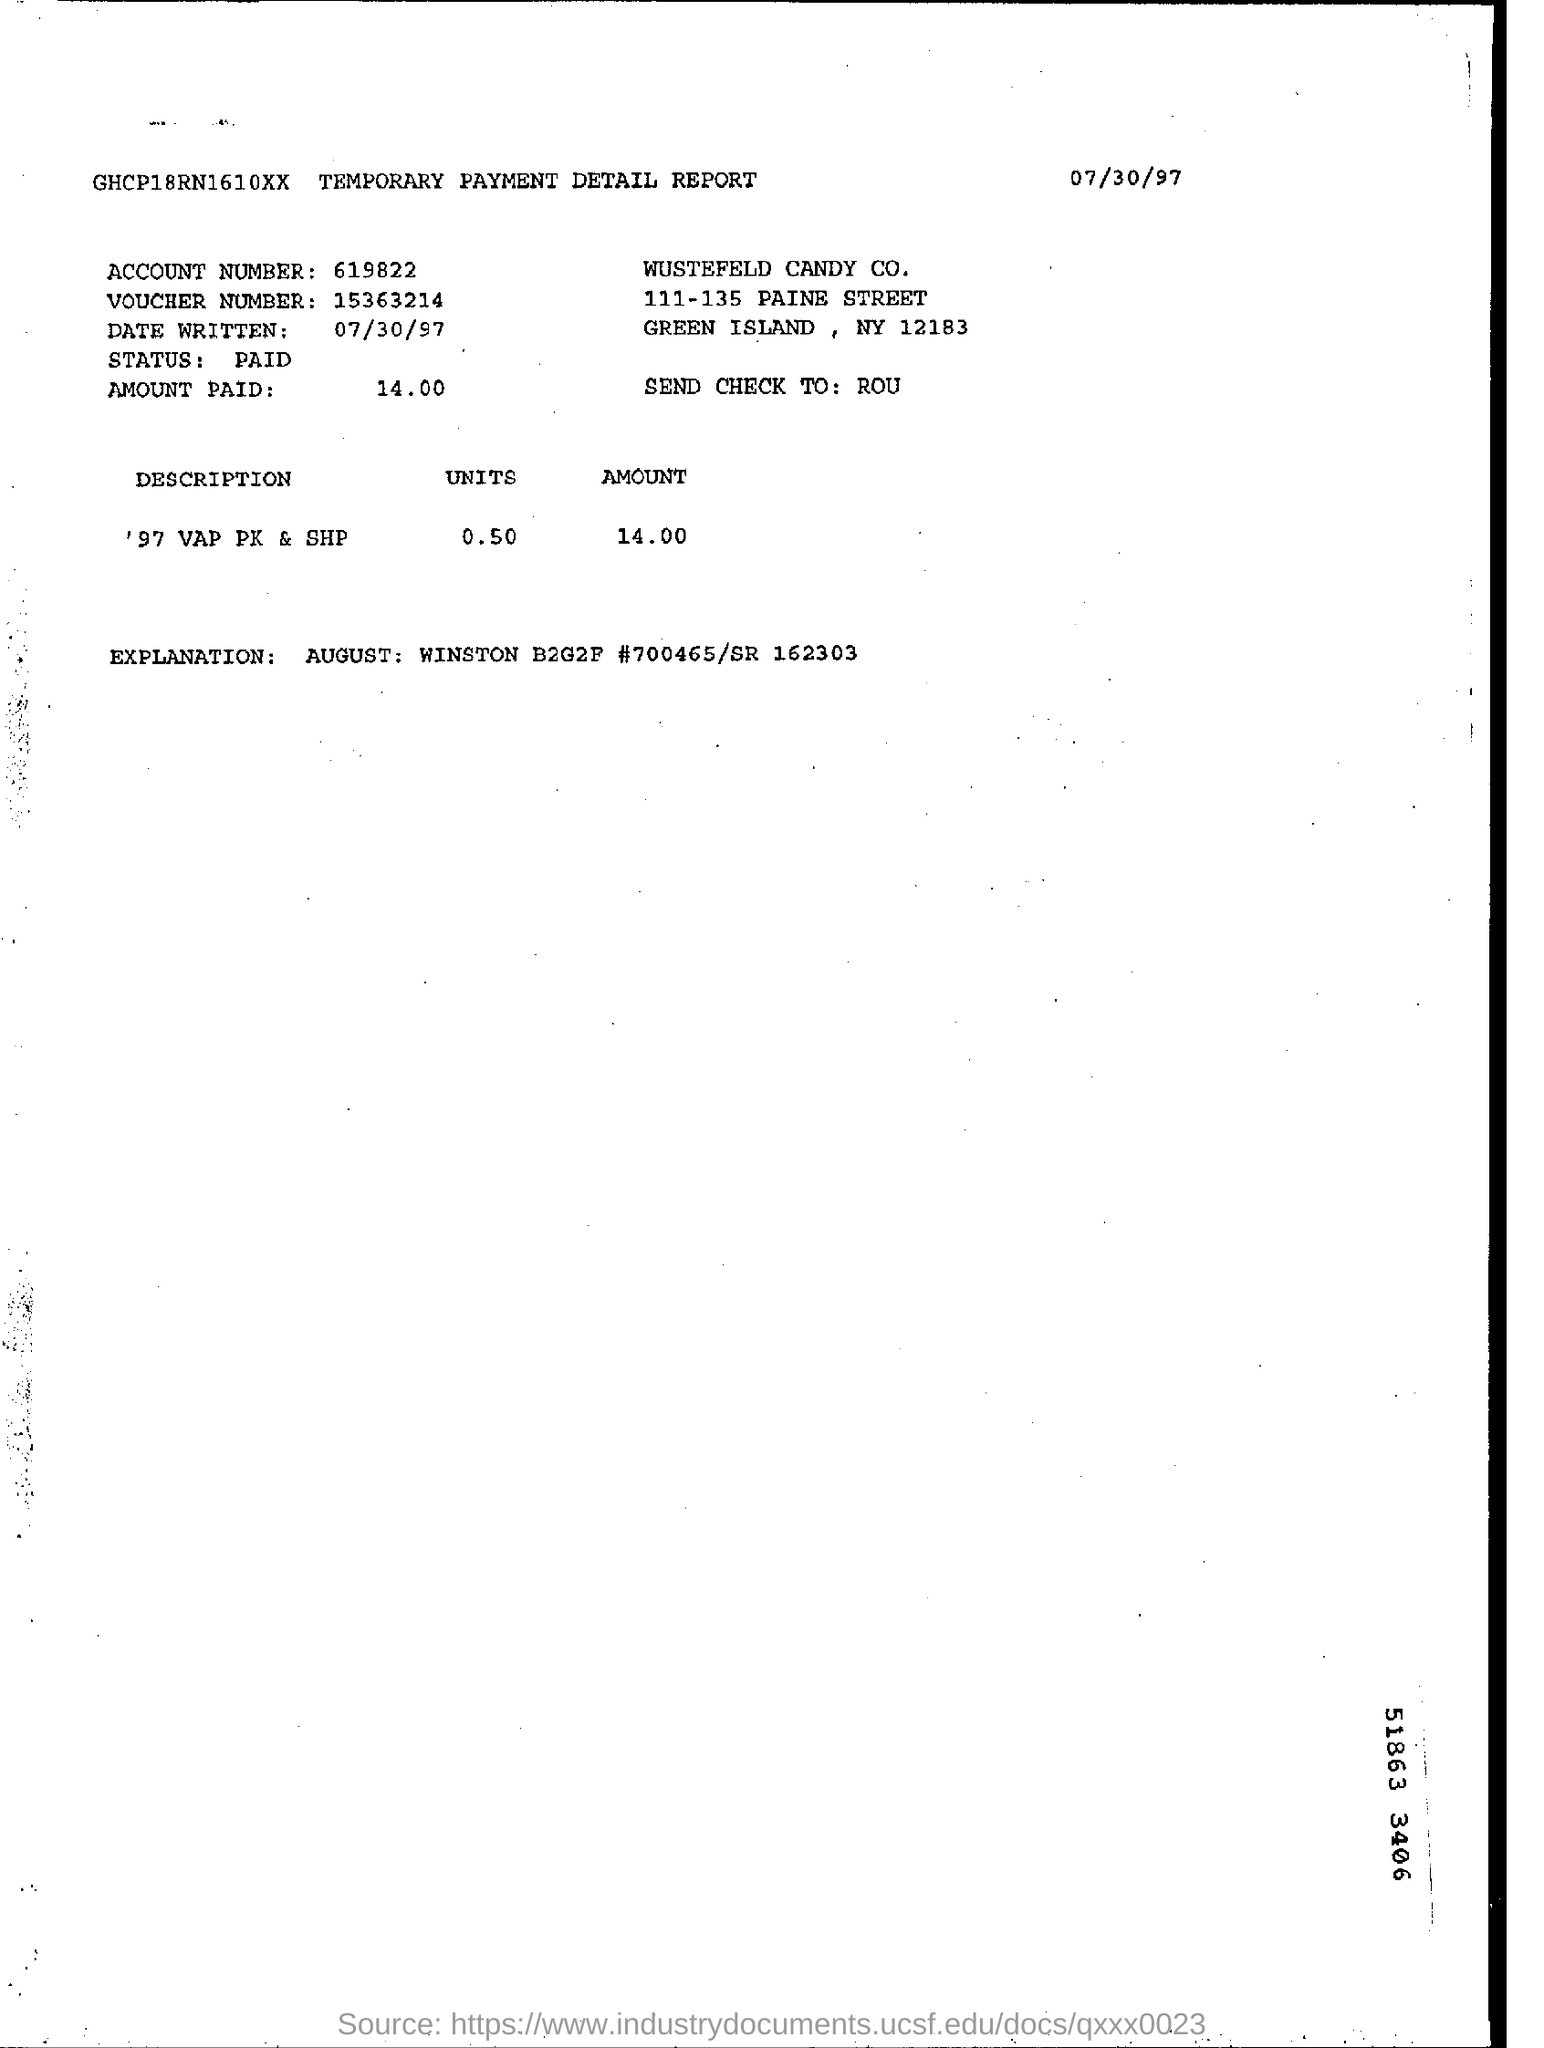What is the status of temporary payment detail report
Your answer should be very brief. Paid. What is the date written on  temporary payment detail report?
Your response must be concise. 07/30/97. 